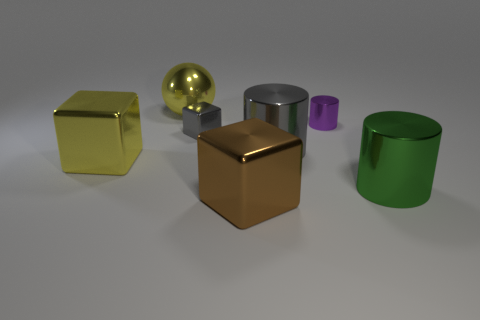The purple metal thing that is the same shape as the large green metal thing is what size?
Make the answer very short. Small. Are there the same number of brown shiny objects that are behind the tiny gray shiny block and yellow blocks?
Offer a very short reply. No. Does the large yellow shiny object that is behind the large yellow block have the same shape as the large gray metal object?
Keep it short and to the point. No. What shape is the big gray metallic thing?
Make the answer very short. Cylinder. The small object left of the large metal cube in front of the thing to the right of the tiny purple cylinder is made of what material?
Your answer should be very brief. Metal. There is a thing that is the same color as the tiny shiny cube; what material is it?
Ensure brevity in your answer.  Metal. How many objects are blue rubber cubes or large green things?
Make the answer very short. 1. Do the yellow thing behind the tiny purple metallic object and the gray cylinder have the same material?
Your answer should be very brief. Yes. How many things are either big cubes that are behind the brown block or gray things?
Your answer should be very brief. 3. What is the color of the ball that is made of the same material as the large gray cylinder?
Offer a terse response. Yellow. 